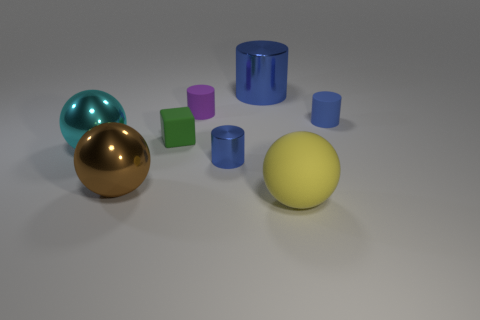Subtract all yellow balls. How many blue cylinders are left? 3 Add 2 small green blocks. How many objects exist? 10 Subtract all balls. How many objects are left? 5 Add 6 small purple cylinders. How many small purple cylinders are left? 7 Add 5 small metal cylinders. How many small metal cylinders exist? 6 Subtract 0 blue cubes. How many objects are left? 8 Subtract all tiny cubes. Subtract all tiny cyan matte spheres. How many objects are left? 7 